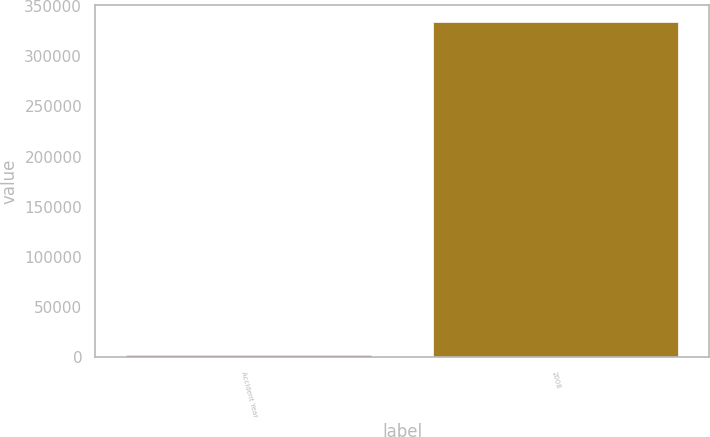Convert chart. <chart><loc_0><loc_0><loc_500><loc_500><bar_chart><fcel>Accident Year<fcel>2008<nl><fcel>2010<fcel>334078<nl></chart> 